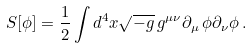<formula> <loc_0><loc_0><loc_500><loc_500>S [ \phi ] = \frac { 1 } { 2 } \int d ^ { 4 } x \sqrt { - { g } } \, { g } ^ { \mu \nu } \partial _ { \mu } \, \phi \partial _ { \nu } \phi \, .</formula> 